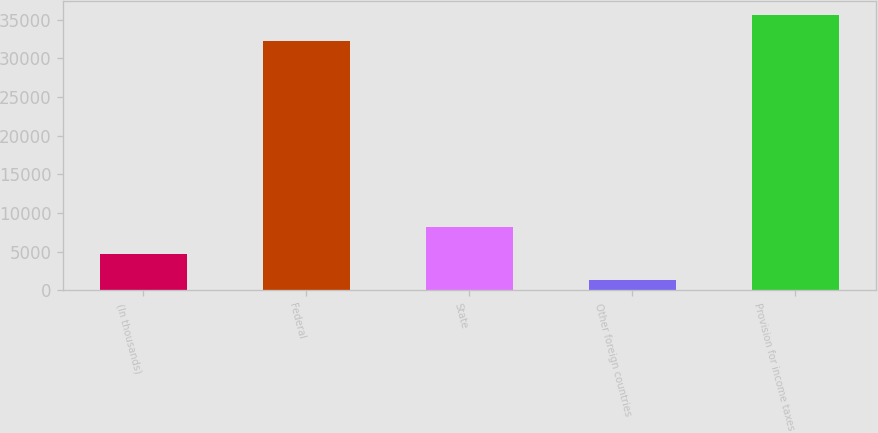Convert chart. <chart><loc_0><loc_0><loc_500><loc_500><bar_chart><fcel>(In thousands)<fcel>Federal<fcel>State<fcel>Other foreign countries<fcel>Provision for income taxes<nl><fcel>4773.8<fcel>32215<fcel>8202.6<fcel>1345<fcel>35643.8<nl></chart> 